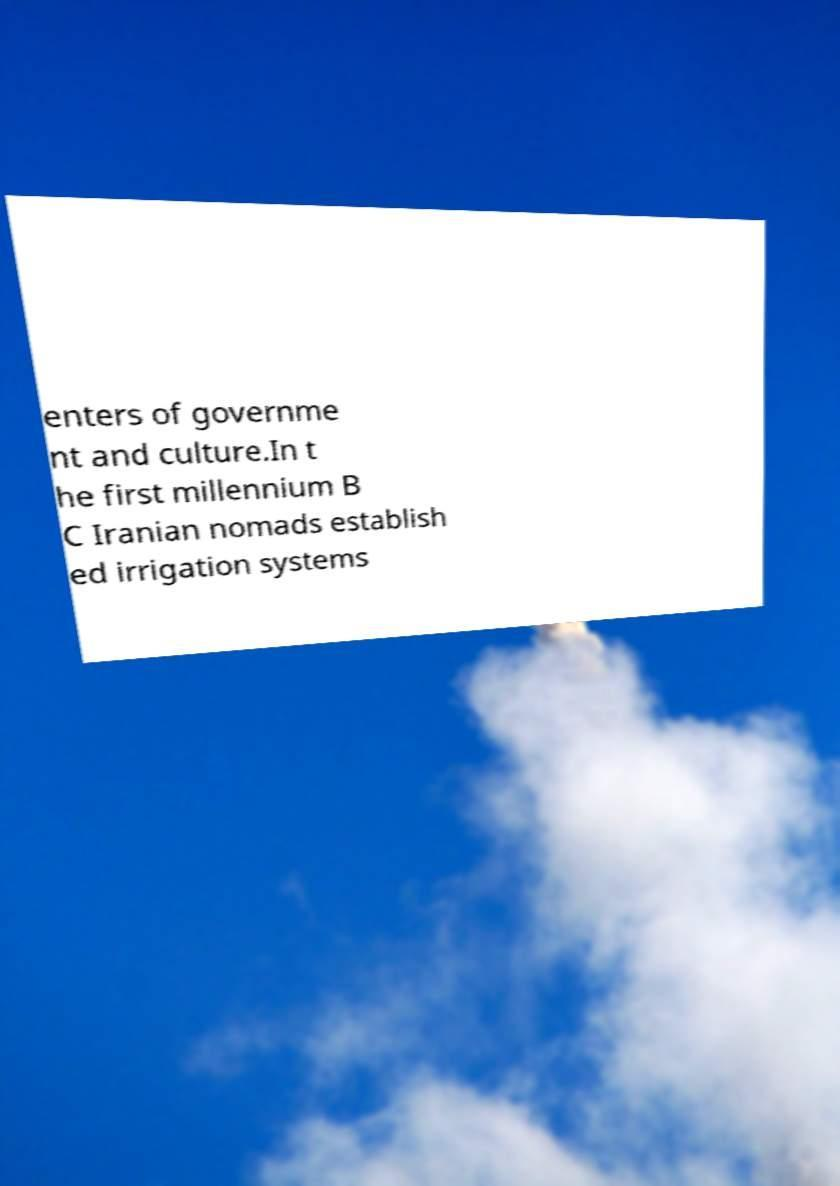Can you read and provide the text displayed in the image?This photo seems to have some interesting text. Can you extract and type it out for me? enters of governme nt and culture.In t he first millennium B C Iranian nomads establish ed irrigation systems 